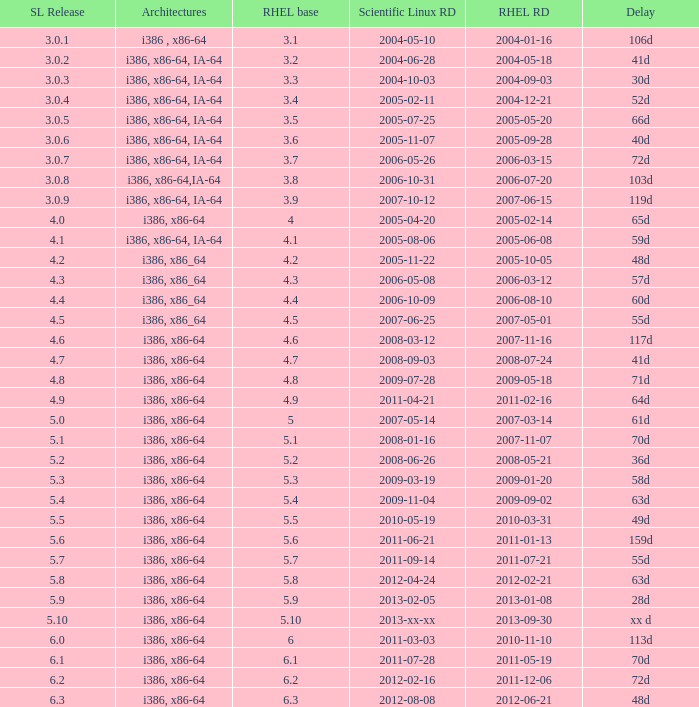Name the delay when scientific linux release is 5.10 Xx d. Would you be able to parse every entry in this table? {'header': ['SL Release', 'Architectures', 'RHEL base', 'Scientific Linux RD', 'RHEL RD', 'Delay'], 'rows': [['3.0.1', 'i386 , x86-64', '3.1', '2004-05-10', '2004-01-16', '106d'], ['3.0.2', 'i386, x86-64, IA-64', '3.2', '2004-06-28', '2004-05-18', '41d'], ['3.0.3', 'i386, x86-64, IA-64', '3.3', '2004-10-03', '2004-09-03', '30d'], ['3.0.4', 'i386, x86-64, IA-64', '3.4', '2005-02-11', '2004-12-21', '52d'], ['3.0.5', 'i386, x86-64, IA-64', '3.5', '2005-07-25', '2005-05-20', '66d'], ['3.0.6', 'i386, x86-64, IA-64', '3.6', '2005-11-07', '2005-09-28', '40d'], ['3.0.7', 'i386, x86-64, IA-64', '3.7', '2006-05-26', '2006-03-15', '72d'], ['3.0.8', 'i386, x86-64,IA-64', '3.8', '2006-10-31', '2006-07-20', '103d'], ['3.0.9', 'i386, x86-64, IA-64', '3.9', '2007-10-12', '2007-06-15', '119d'], ['4.0', 'i386, x86-64', '4', '2005-04-20', '2005-02-14', '65d'], ['4.1', 'i386, x86-64, IA-64', '4.1', '2005-08-06', '2005-06-08', '59d'], ['4.2', 'i386, x86_64', '4.2', '2005-11-22', '2005-10-05', '48d'], ['4.3', 'i386, x86_64', '4.3', '2006-05-08', '2006-03-12', '57d'], ['4.4', 'i386, x86_64', '4.4', '2006-10-09', '2006-08-10', '60d'], ['4.5', 'i386, x86_64', '4.5', '2007-06-25', '2007-05-01', '55d'], ['4.6', 'i386, x86-64', '4.6', '2008-03-12', '2007-11-16', '117d'], ['4.7', 'i386, x86-64', '4.7', '2008-09-03', '2008-07-24', '41d'], ['4.8', 'i386, x86-64', '4.8', '2009-07-28', '2009-05-18', '71d'], ['4.9', 'i386, x86-64', '4.9', '2011-04-21', '2011-02-16', '64d'], ['5.0', 'i386, x86-64', '5', '2007-05-14', '2007-03-14', '61d'], ['5.1', 'i386, x86-64', '5.1', '2008-01-16', '2007-11-07', '70d'], ['5.2', 'i386, x86-64', '5.2', '2008-06-26', '2008-05-21', '36d'], ['5.3', 'i386, x86-64', '5.3', '2009-03-19', '2009-01-20', '58d'], ['5.4', 'i386, x86-64', '5.4', '2009-11-04', '2009-09-02', '63d'], ['5.5', 'i386, x86-64', '5.5', '2010-05-19', '2010-03-31', '49d'], ['5.6', 'i386, x86-64', '5.6', '2011-06-21', '2011-01-13', '159d'], ['5.7', 'i386, x86-64', '5.7', '2011-09-14', '2011-07-21', '55d'], ['5.8', 'i386, x86-64', '5.8', '2012-04-24', '2012-02-21', '63d'], ['5.9', 'i386, x86-64', '5.9', '2013-02-05', '2013-01-08', '28d'], ['5.10', 'i386, x86-64', '5.10', '2013-xx-xx', '2013-09-30', 'xx d'], ['6.0', 'i386, x86-64', '6', '2011-03-03', '2010-11-10', '113d'], ['6.1', 'i386, x86-64', '6.1', '2011-07-28', '2011-05-19', '70d'], ['6.2', 'i386, x86-64', '6.2', '2012-02-16', '2011-12-06', '72d'], ['6.3', 'i386, x86-64', '6.3', '2012-08-08', '2012-06-21', '48d']]} 